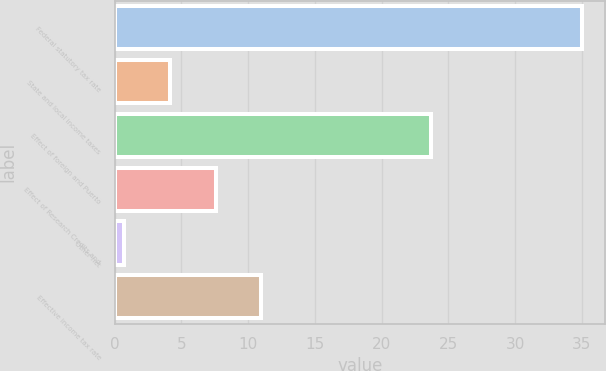<chart> <loc_0><loc_0><loc_500><loc_500><bar_chart><fcel>Federal statutory tax rate<fcel>State and local income taxes<fcel>Effect of foreign and Puerto<fcel>Effect of Research Credits and<fcel>Other net<fcel>Effective income tax rate<nl><fcel>35<fcel>4.13<fcel>23.7<fcel>7.56<fcel>0.7<fcel>10.99<nl></chart> 